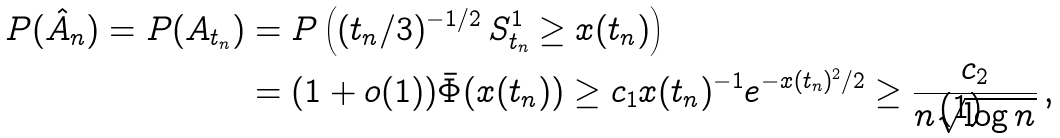Convert formula to latex. <formula><loc_0><loc_0><loc_500><loc_500>P ( \hat { A } _ { n } ) = P ( A _ { t _ { n } } ) & = P \left ( ( t _ { n } / 3 ) ^ { - 1 / 2 } \, S _ { t _ { n } } ^ { 1 } \geq x ( t _ { n } ) \right ) \\ & = ( 1 + o ( 1 ) ) \bar { \Phi } ( x ( t _ { n } ) ) \geq c _ { 1 } x ( t _ { n } ) ^ { - 1 } e ^ { - x ( t _ { n } ) ^ { 2 } / 2 } \geq \frac { c _ { 2 } } { n \sqrt { \log n } } \, ,</formula> 